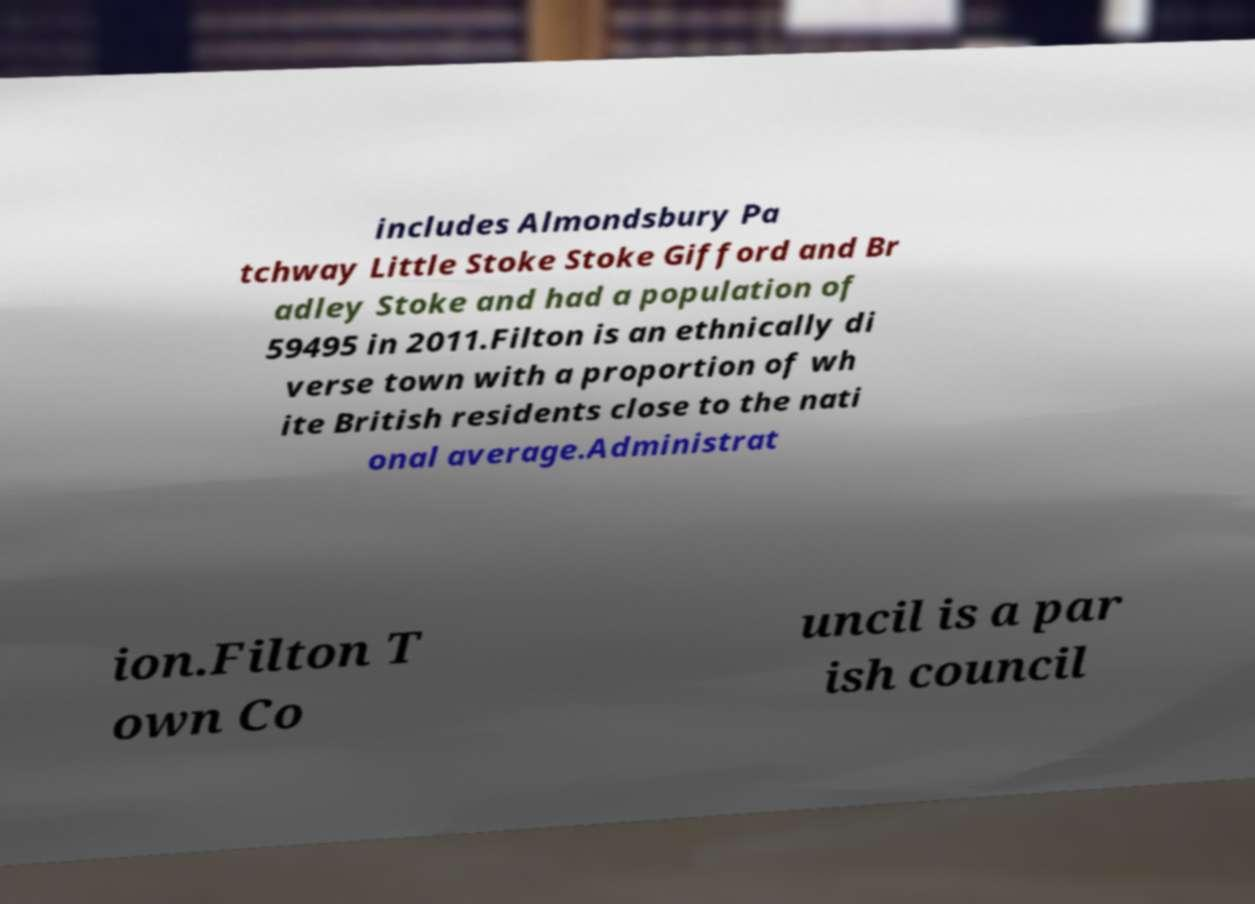For documentation purposes, I need the text within this image transcribed. Could you provide that? includes Almondsbury Pa tchway Little Stoke Stoke Gifford and Br adley Stoke and had a population of 59495 in 2011.Filton is an ethnically di verse town with a proportion of wh ite British residents close to the nati onal average.Administrat ion.Filton T own Co uncil is a par ish council 